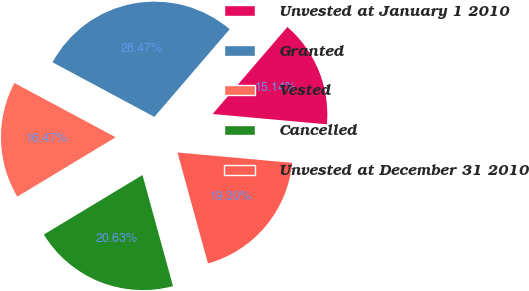Convert chart to OTSL. <chart><loc_0><loc_0><loc_500><loc_500><pie_chart><fcel>Unvested at January 1 2010<fcel>Granted<fcel>Vested<fcel>Cancelled<fcel>Unvested at December 31 2010<nl><fcel>15.14%<fcel>28.47%<fcel>16.47%<fcel>20.63%<fcel>19.3%<nl></chart> 